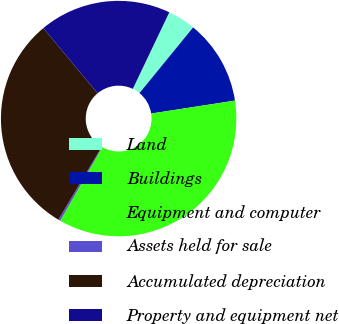<chart> <loc_0><loc_0><loc_500><loc_500><pie_chart><fcel>Land<fcel>Buildings<fcel>Equipment and computer<fcel>Assets held for sale<fcel>Accumulated depreciation<fcel>Property and equipment net<nl><fcel>3.82%<fcel>11.66%<fcel>35.71%<fcel>0.28%<fcel>30.4%<fcel>18.13%<nl></chart> 